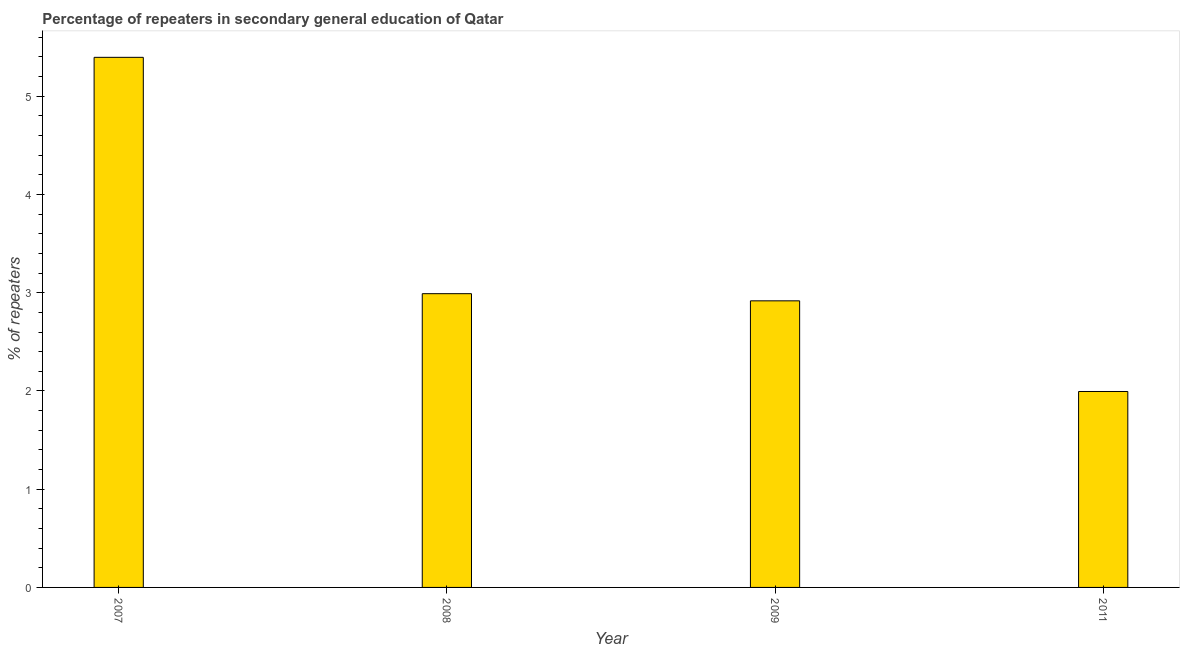Does the graph contain any zero values?
Provide a succinct answer. No. What is the title of the graph?
Keep it short and to the point. Percentage of repeaters in secondary general education of Qatar. What is the label or title of the Y-axis?
Provide a succinct answer. % of repeaters. What is the percentage of repeaters in 2008?
Offer a very short reply. 2.99. Across all years, what is the maximum percentage of repeaters?
Ensure brevity in your answer.  5.4. Across all years, what is the minimum percentage of repeaters?
Offer a very short reply. 1.99. What is the sum of the percentage of repeaters?
Your answer should be compact. 13.3. What is the average percentage of repeaters per year?
Provide a short and direct response. 3.33. What is the median percentage of repeaters?
Keep it short and to the point. 2.95. What is the ratio of the percentage of repeaters in 2009 to that in 2011?
Your answer should be very brief. 1.46. Is the percentage of repeaters in 2007 less than that in 2009?
Keep it short and to the point. No. What is the difference between the highest and the second highest percentage of repeaters?
Your answer should be compact. 2.41. Is the sum of the percentage of repeaters in 2008 and 2011 greater than the maximum percentage of repeaters across all years?
Offer a very short reply. No. In how many years, is the percentage of repeaters greater than the average percentage of repeaters taken over all years?
Give a very brief answer. 1. How many years are there in the graph?
Your answer should be very brief. 4. What is the % of repeaters of 2007?
Your answer should be very brief. 5.4. What is the % of repeaters of 2008?
Offer a very short reply. 2.99. What is the % of repeaters in 2009?
Keep it short and to the point. 2.92. What is the % of repeaters in 2011?
Provide a short and direct response. 1.99. What is the difference between the % of repeaters in 2007 and 2008?
Keep it short and to the point. 2.41. What is the difference between the % of repeaters in 2007 and 2009?
Provide a short and direct response. 2.48. What is the difference between the % of repeaters in 2007 and 2011?
Your answer should be compact. 3.4. What is the difference between the % of repeaters in 2008 and 2009?
Offer a very short reply. 0.07. What is the difference between the % of repeaters in 2008 and 2011?
Give a very brief answer. 1. What is the difference between the % of repeaters in 2009 and 2011?
Make the answer very short. 0.92. What is the ratio of the % of repeaters in 2007 to that in 2008?
Your response must be concise. 1.8. What is the ratio of the % of repeaters in 2007 to that in 2009?
Provide a succinct answer. 1.85. What is the ratio of the % of repeaters in 2007 to that in 2011?
Offer a very short reply. 2.71. What is the ratio of the % of repeaters in 2008 to that in 2009?
Keep it short and to the point. 1.02. What is the ratio of the % of repeaters in 2008 to that in 2011?
Keep it short and to the point. 1.5. What is the ratio of the % of repeaters in 2009 to that in 2011?
Provide a short and direct response. 1.46. 